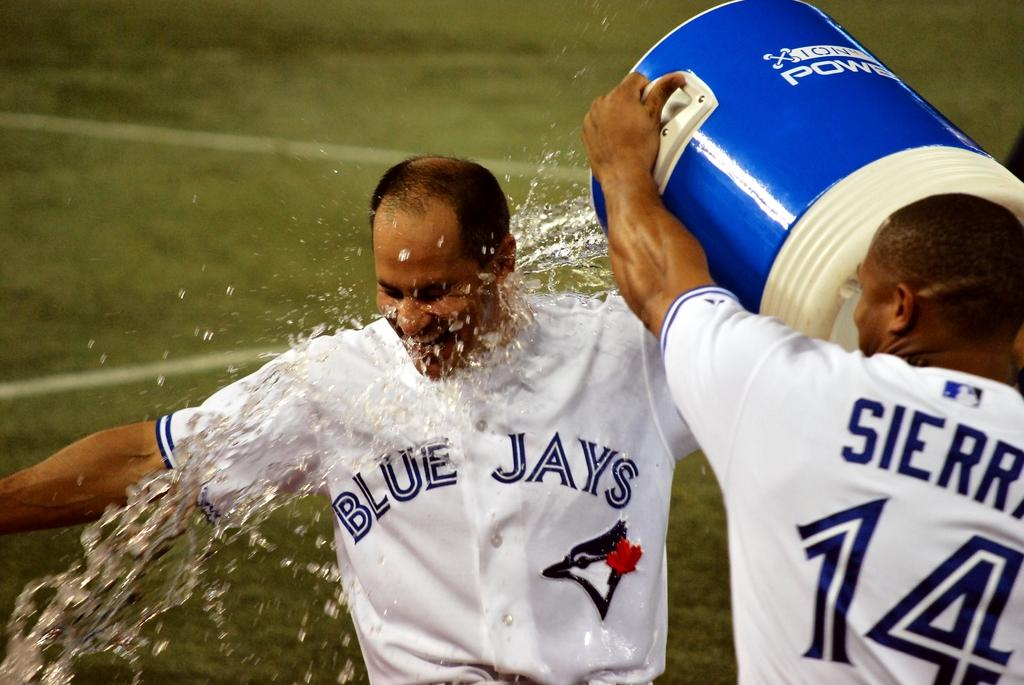<image>
Relay a brief, clear account of the picture shown. One blue jays player is getting alot of water poured over them by another player. 